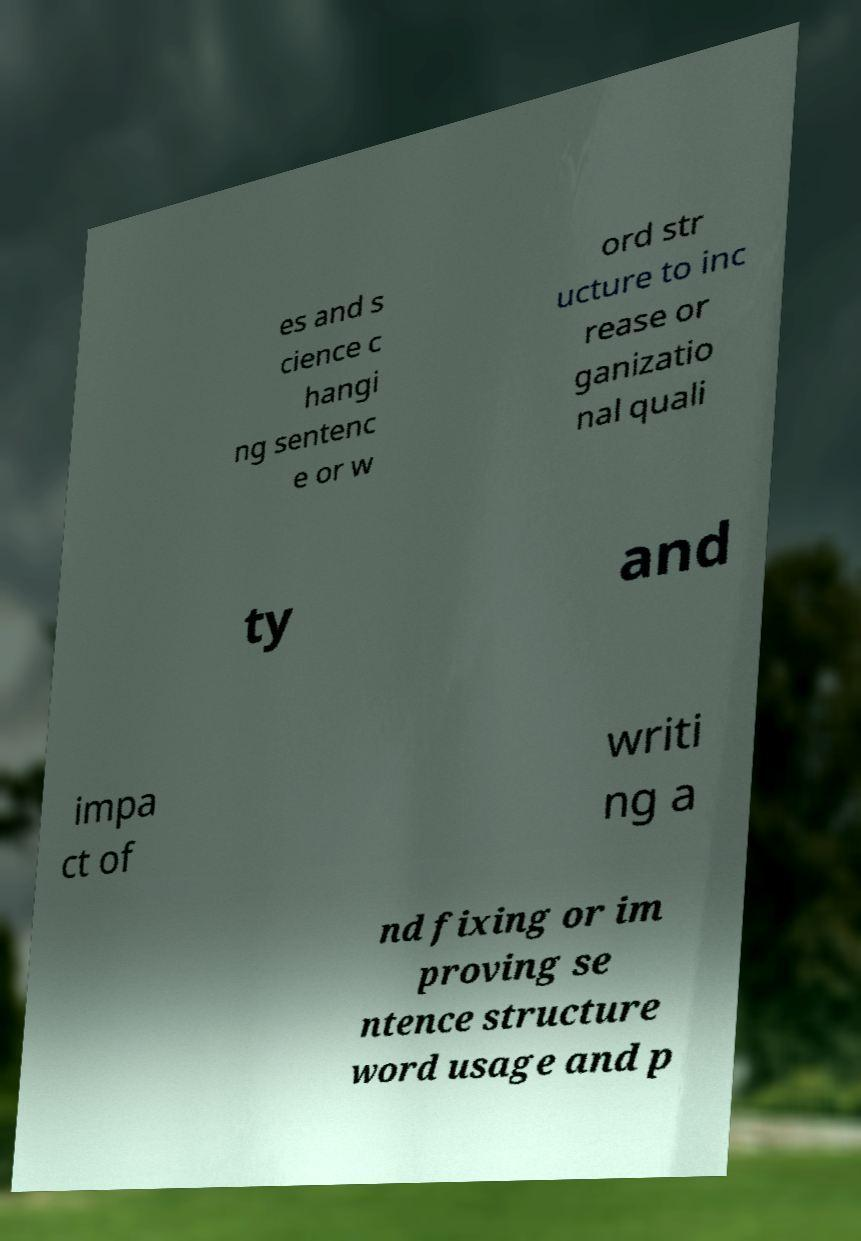Can you read and provide the text displayed in the image?This photo seems to have some interesting text. Can you extract and type it out for me? es and s cience c hangi ng sentenc e or w ord str ucture to inc rease or ganizatio nal quali ty and impa ct of writi ng a nd fixing or im proving se ntence structure word usage and p 